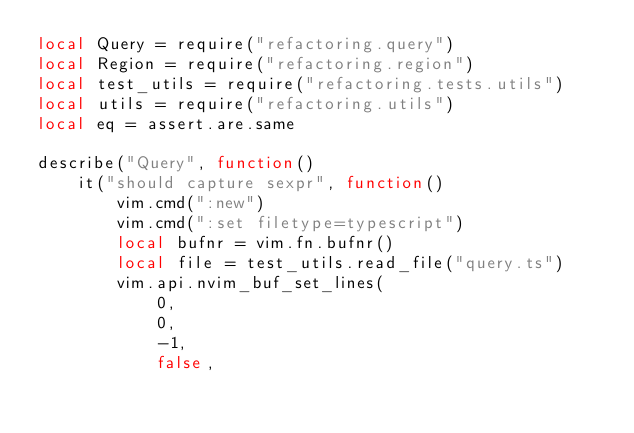Convert code to text. <code><loc_0><loc_0><loc_500><loc_500><_Lua_>local Query = require("refactoring.query")
local Region = require("refactoring.region")
local test_utils = require("refactoring.tests.utils")
local utils = require("refactoring.utils")
local eq = assert.are.same

describe("Query", function()
    it("should capture sexpr", function()
        vim.cmd(":new")
        vim.cmd(":set filetype=typescript")
        local bufnr = vim.fn.bufnr()
        local file = test_utils.read_file("query.ts")
        vim.api.nvim_buf_set_lines(
            0,
            0,
            -1,
            false,</code> 